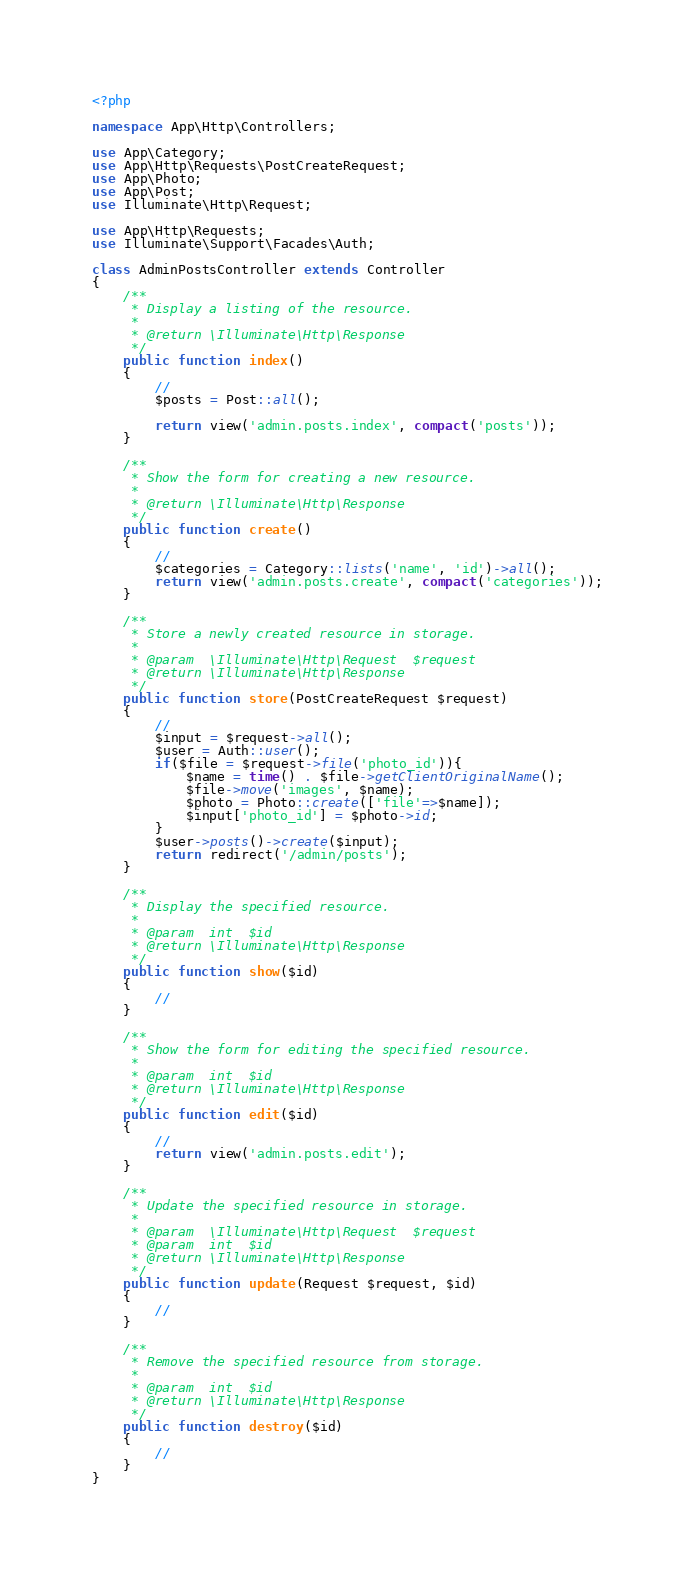<code> <loc_0><loc_0><loc_500><loc_500><_PHP_><?php

namespace App\Http\Controllers;

use App\Category;
use App\Http\Requests\PostCreateRequest;
use App\Photo;
use App\Post;
use Illuminate\Http\Request;

use App\Http\Requests;
use Illuminate\Support\Facades\Auth;

class AdminPostsController extends Controller
{
    /**
     * Display a listing of the resource.
     *
     * @return \Illuminate\Http\Response
     */
    public function index()
    {
        //
        $posts = Post::all();

        return view('admin.posts.index', compact('posts'));
    }

    /**
     * Show the form for creating a new resource.
     *
     * @return \Illuminate\Http\Response
     */
    public function create()
    {
        //
        $categories = Category::lists('name', 'id')->all();
        return view('admin.posts.create', compact('categories'));
    }

    /**
     * Store a newly created resource in storage.
     *
     * @param  \Illuminate\Http\Request  $request
     * @return \Illuminate\Http\Response
     */
    public function store(PostCreateRequest $request)
    {
        //
        $input = $request->all();
        $user = Auth::user();
        if($file = $request->file('photo_id')){
            $name = time() . $file->getClientOriginalName();
            $file->move('images', $name);
            $photo = Photo::create(['file'=>$name]);
            $input['photo_id'] = $photo->id;
        }
        $user->posts()->create($input);
        return redirect('/admin/posts');
    }

    /**
     * Display the specified resource.
     *
     * @param  int  $id
     * @return \Illuminate\Http\Response
     */
    public function show($id)
    {
        //
    }

    /**
     * Show the form for editing the specified resource.
     *
     * @param  int  $id
     * @return \Illuminate\Http\Response
     */
    public function edit($id)
    {
        //
        return view('admin.posts.edit');
    }

    /**
     * Update the specified resource in storage.
     *
     * @param  \Illuminate\Http\Request  $request
     * @param  int  $id
     * @return \Illuminate\Http\Response
     */
    public function update(Request $request, $id)
    {
        //
    }

    /**
     * Remove the specified resource from storage.
     *
     * @param  int  $id
     * @return \Illuminate\Http\Response
     */
    public function destroy($id)
    {
        //
    }
}
</code> 